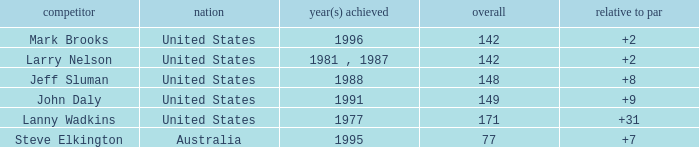Name the Total of australia and a To par smaller than 7? None. 